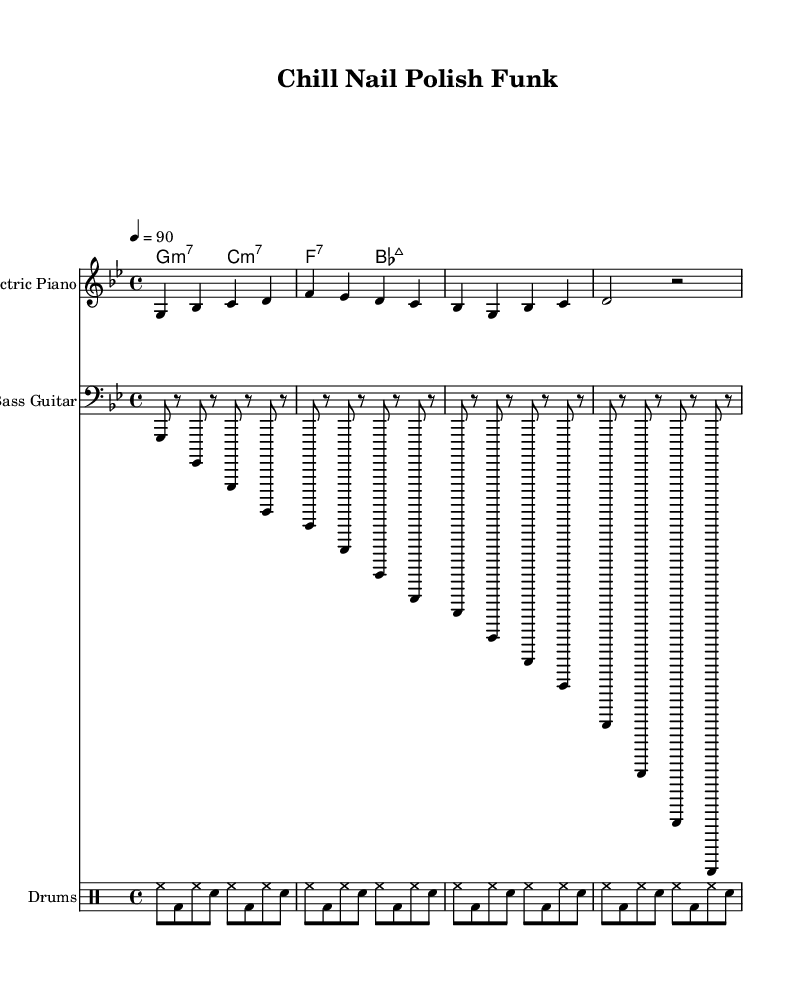What is the key signature of this music? The key signature is G minor, which contains two flats: B flat and E flat. This can be inferred from the indication in the "global" section of the sheet music.
Answer: G minor What is the time signature of this piece? The time signature is 4/4, indicated in the "global" section of the sheet music. This means there are four beats in each measure and the quarter note gets one beat.
Answer: 4/4 What is the tempo marking for this composition? The tempo is marked as 90 beats per minute, which suggests a moderate pace. This is found in the "global" section under tempo.
Answer: 90 What is the instrument primarily playing the melody? The instrument playing the melody is the electric piano, as specified in the staff's instrument name at the beginning of its section.
Answer: Electric Piano How many measures does the electric piano part have? The electric piano part has a total of four measures. This can be seen in the layout where each line contains one measure, and there are four lines represented.
Answer: Four measures What types of chords are used in the chord progression? The chords used in the progression are minor seventh and major seventh chords, as indicated by the chord names in the "ChordNames" section: G minor 7, C minor 7, F dominant 7, and B flat major 7.
Answer: Minor and Major seventh chords What is the primary rhythmic pattern used by the drums? The predominant rhythmic pattern in the drum part is a hi-hat (hh) followed by a bass drum (bd) and snare drum (sn), creating a consistent groove throughout the composition. This is identifiable from the repeated sequence in the drum notation.
Answer: Hi-hat, bass drum, snare 